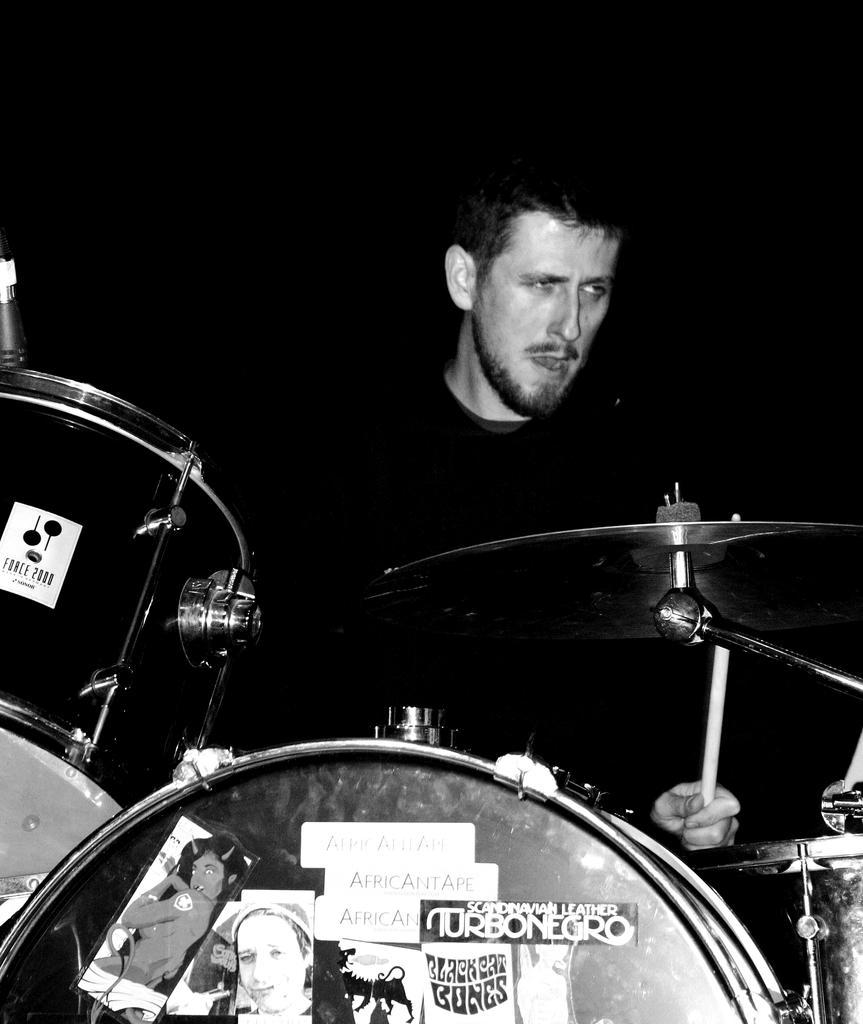Could you give a brief overview of what you see in this image? In the image in the center we can see one person holding stick. In the bottom of the image we can see few musical instruments. 